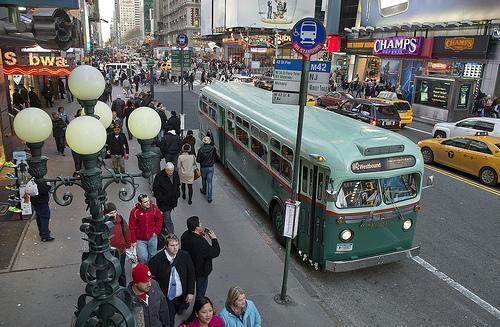How many buses are there?
Give a very brief answer. 1. 